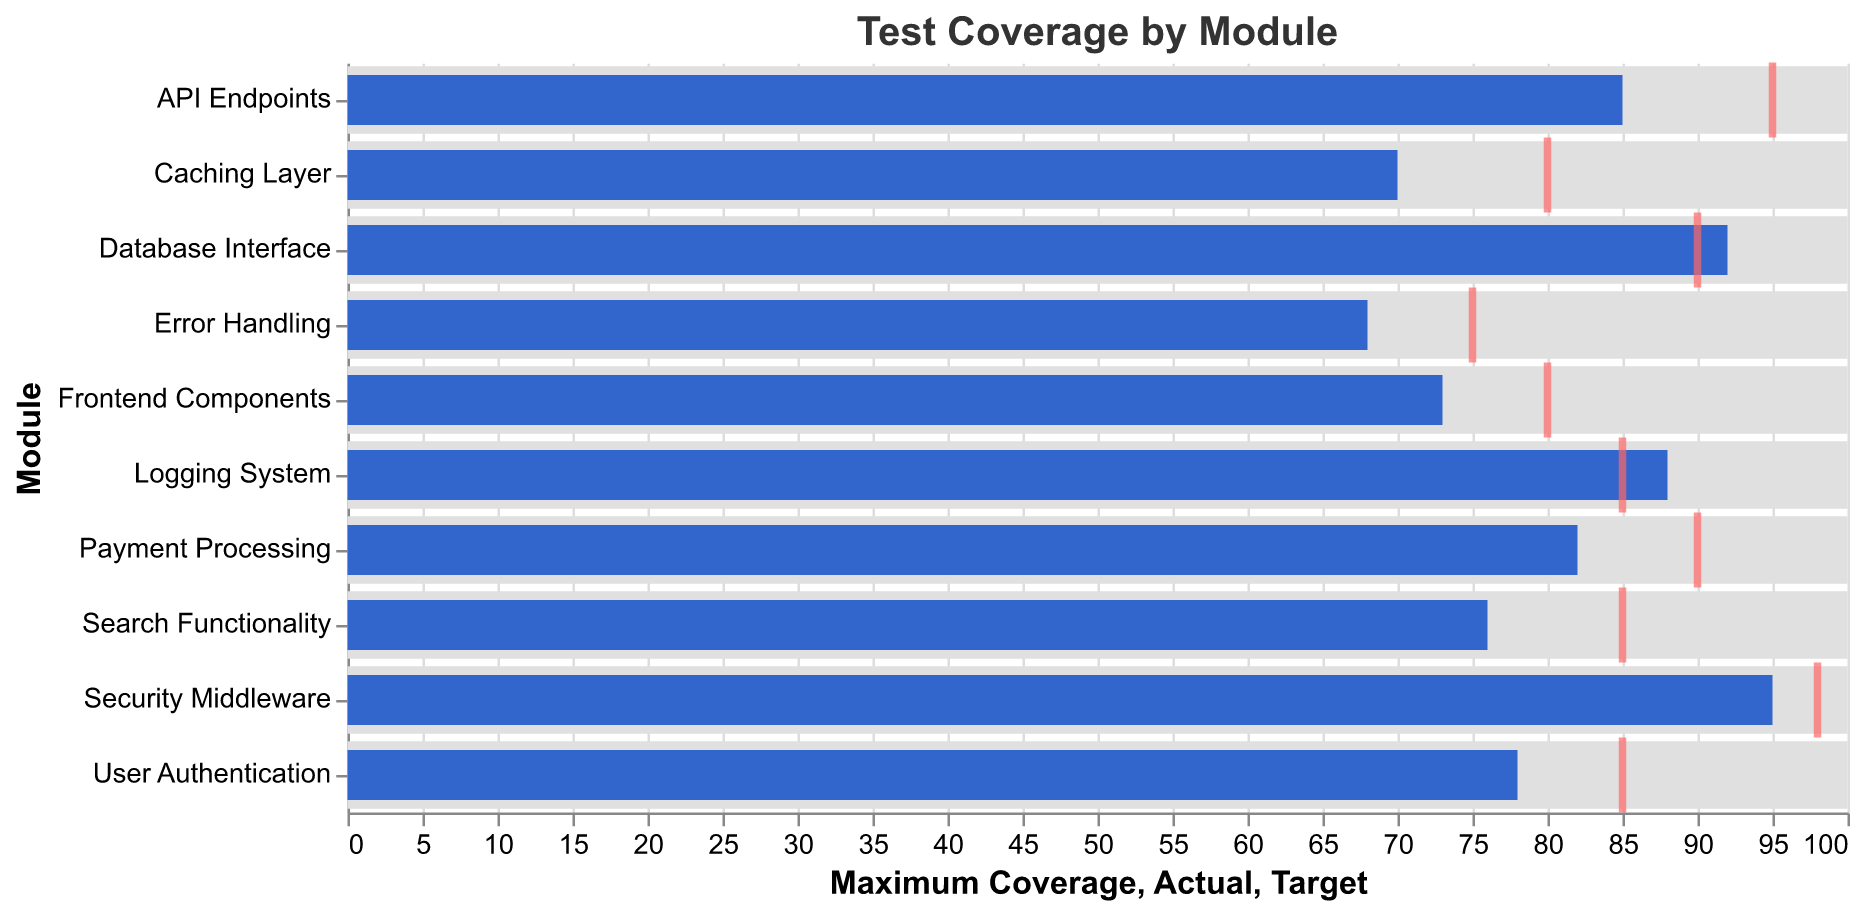What is the title of the figure? The title is positioned at the top of the figure, it reads "Test Coverage by Module".
Answer: Test Coverage by Module Which module has the highest actual coverage? Look for the module with the bar that reaches the furthest to the right in the chart. The "Security Middleware" module has the highest actual coverage at 95%.
Answer: Security Middleware What is the desired coverage for the "Frontend Components" module? Locate the "Frontend Components" module on the y-axis and note the position of the red tick mark representing desired coverage, which is at 80% on the x-axis.
Answer: 80% Which module falls short the most in terms of achieving the desired coverage? Compare the distances between the actual coverage bar and the desired coverage tick for each module. The module with the largest gap is "API Endpoints," with a 10% shortfall (desired at 95%, actual at 85%).
Answer: API Endpoints How many modules meet or exceed their desired coverage levels? Count the number of modules where the actual coverage bar is equal to or greater than the desired coverage tick. These modules are "Database Interface," "Logging System," and "Security Middleware".
Answer: 3 What is the overall trend in test coverage? Observing the entire chart, most modules have actual coverage below their desired levels, indicating a general shortfall in meeting set coverage goals.
Answer: General shortfall in meeting coverage goals For which module is the difference between actual and desired coverage the smallest? Check each module's gap between actual and desired coverage. "Database Interface" has the smallest difference with actual at 92% and desired at 90%, a 2% discrepancy.
Answer: Database Interface Compare the actual coverage of "User Authentication" and "Search Functionality". Which has higher coverage? Locate both modules on the y-axis and compare the lengths of the bars. "User Authentication" has higher actual coverage at 78%, compared to "Search Functionality" at 76%.
Answer: User Authentication Which module's actual coverage is equal to its desired coverage? Scan through the chart to find modules where the blue bar (actual) aligns exactly with the red tick (desired). "Logging System" is the only module meeting this criterion at 88%.
Answer: Logging System 